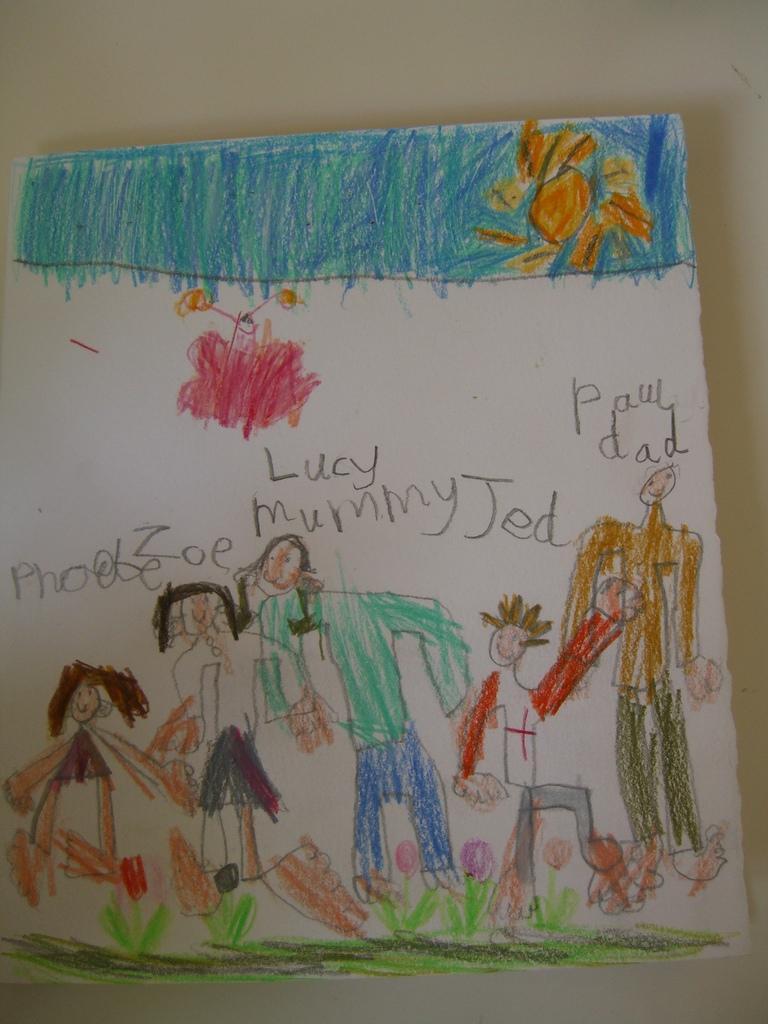In one or two sentences, can you explain what this image depicts? In this image, I can see a paper with a drawing on it. This looks like a wall. 